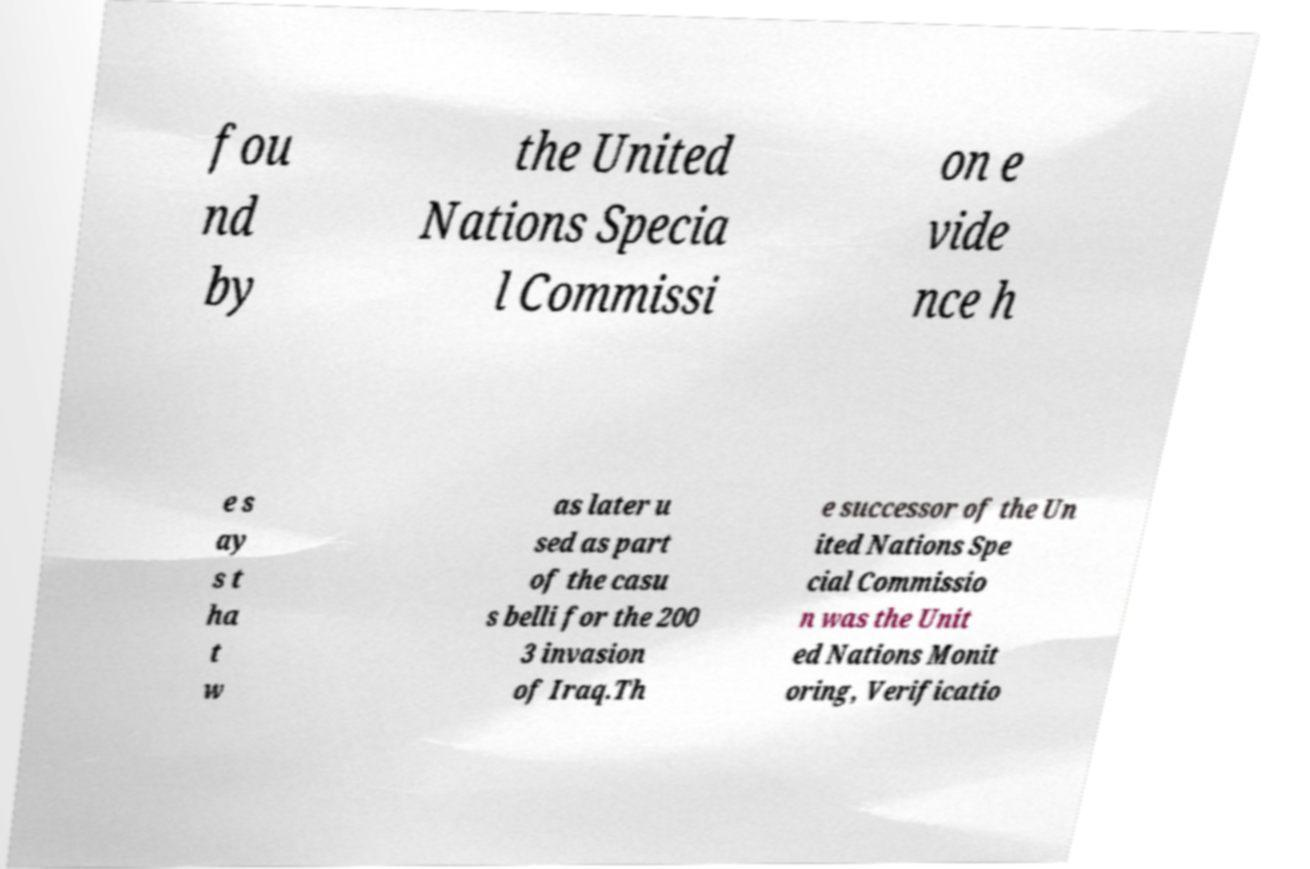For documentation purposes, I need the text within this image transcribed. Could you provide that? fou nd by the United Nations Specia l Commissi on e vide nce h e s ay s t ha t w as later u sed as part of the casu s belli for the 200 3 invasion of Iraq.Th e successor of the Un ited Nations Spe cial Commissio n was the Unit ed Nations Monit oring, Verificatio 